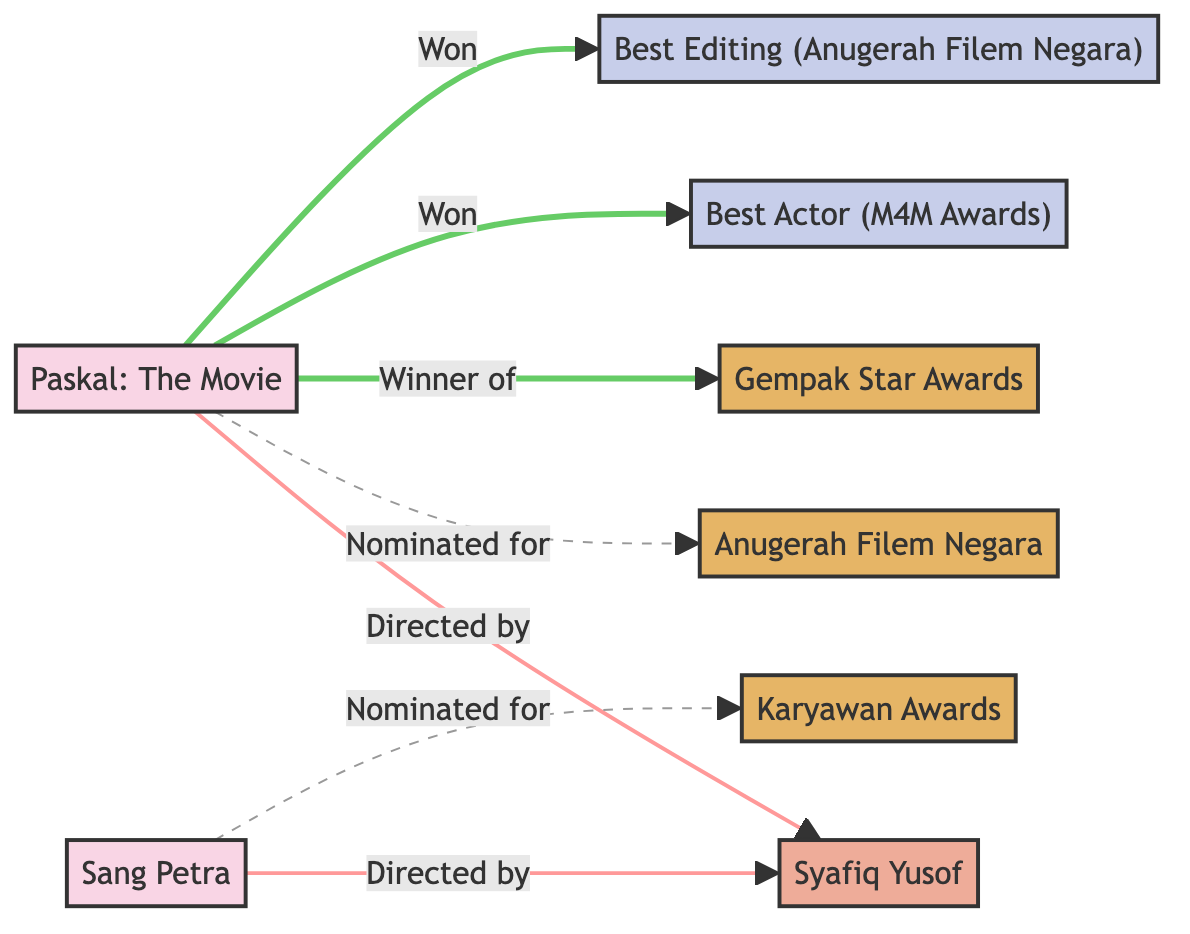What film is directed by Syafiq Yusof? The node "Syafiq Yusof" connects to "Paskal" and "Sang Petra" through the relationship "Directed by." Therefore, both films are directed by him.
Answer: Paskal, Sang Petra How many awards is Paskal nominated for? In the edges connected to "Paskal," there is one edge indicating a nomination for "Anugerah Filem Negara." This shows that "Paskal" has been nominated for one award.
Answer: 1 Who won Best Actor at the M4M Awards? The edge from "Paskal" to "Best Actor (M4M Awards)" indicates that "Paskal" won this particular award. Therefore, the person receiving this title in relation to "Paskal" is represented through this node.
Answer: Paskal What is one award Sang Petra was nominated for? The diagram specifies that "Sang Petra" has a dashed edge connecting it to "Karyawan Awards," indicating it was nominated for this particular award.
Answer: Karyawan Awards What are the two achievements won by Paskal? The edges from "Paskal" leading to "Best Actor (M4M Awards)" and "Best Editing (Anugerah Filem Negara)" indicate that "Paskal" won both of these achievements.
Answer: Best Actor, Best Editing How many filmmakers directed the films shown in the graph? Both "Paskal" and "Sang Petra," connected to the same filmmaker "Syafiq Yusof," indicate that there is one filmmaker associated with the films in the diagram.
Answer: 1 Which award has Paskal won? There is a directed edge from "Paskal" to "Gempak Star Awards," indicating that "Paskal" is the winner of this award.
Answer: Gempak Star Awards What type of relationship connects Sang Petra and Syafiq Yusof? The relationship is indicated by a solid line connecting "Sang Petra" and "Syafiq Yusof" marked as "Directed by." This denotes that Syafiq Yusof is the director of "Sang Petra."
Answer: Directed by 